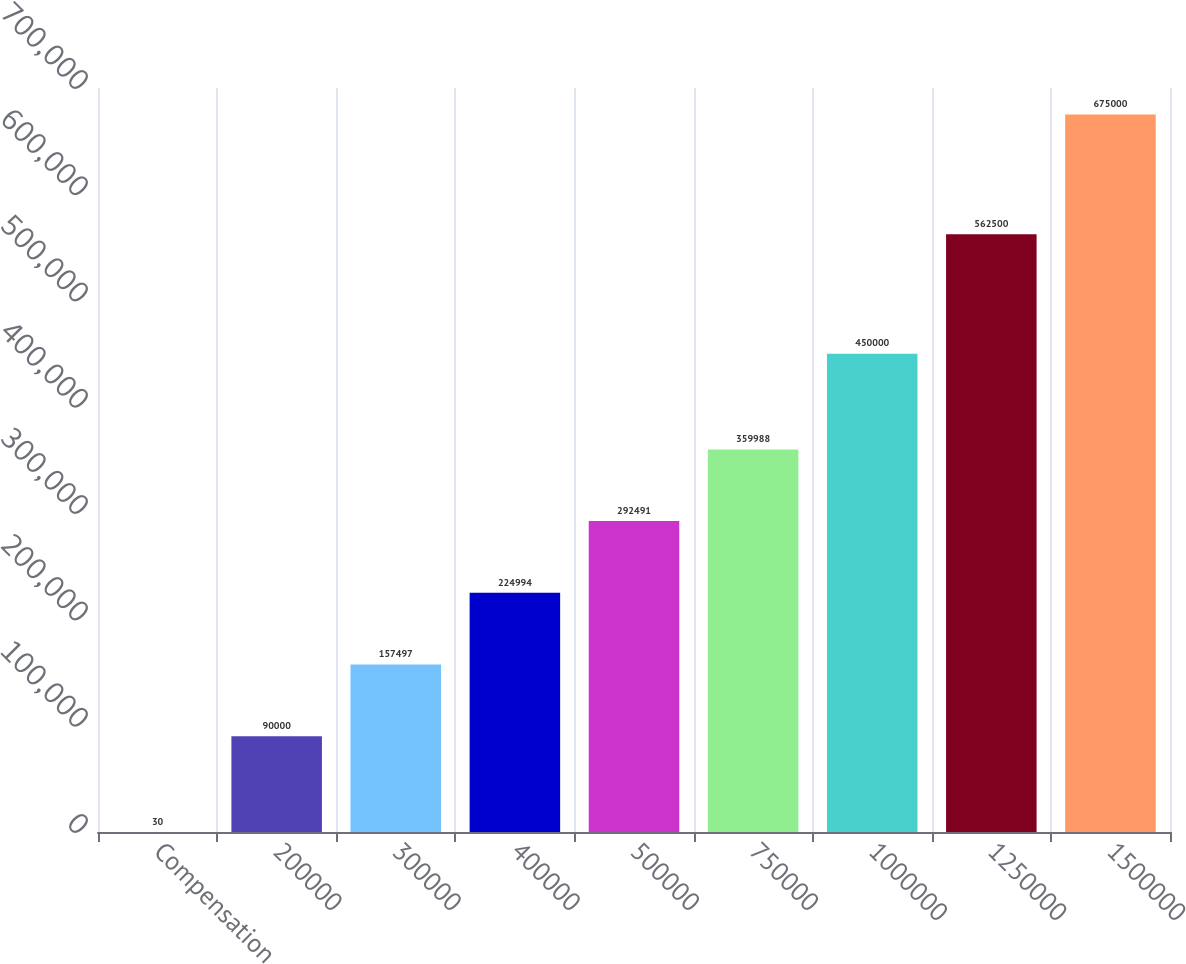Convert chart to OTSL. <chart><loc_0><loc_0><loc_500><loc_500><bar_chart><fcel>Compensation<fcel>200000<fcel>300000<fcel>400000<fcel>500000<fcel>750000<fcel>1000000<fcel>1250000<fcel>1500000<nl><fcel>30<fcel>90000<fcel>157497<fcel>224994<fcel>292491<fcel>359988<fcel>450000<fcel>562500<fcel>675000<nl></chart> 